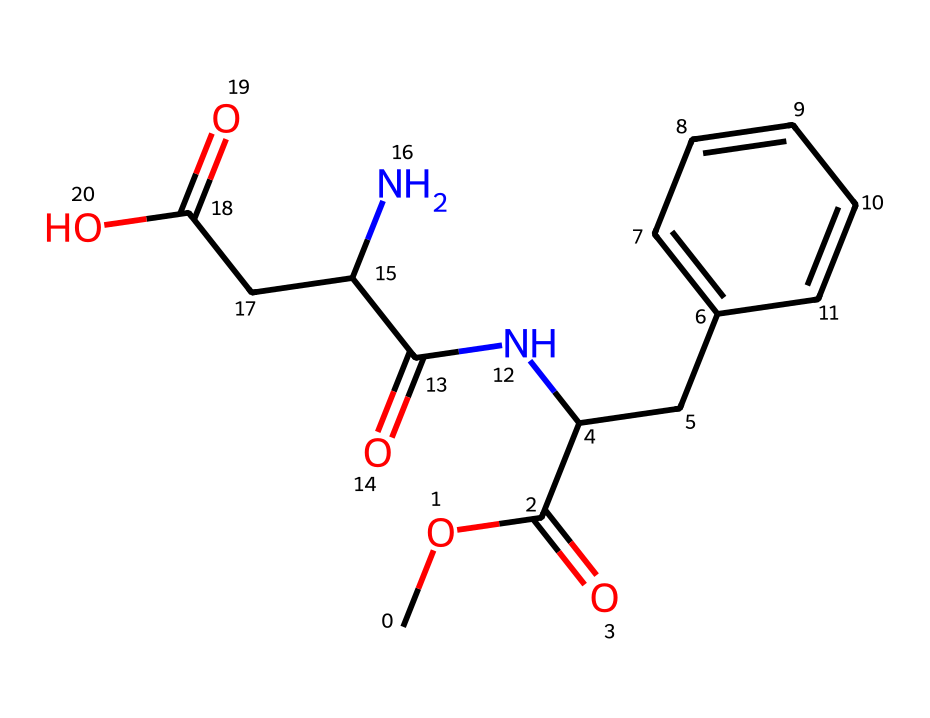what is the name of this compound? This compound is known as aspartame, which is derived from its structure containing both aspartic acid and phenylalanine.
Answer: aspartame how many carbon atoms are present? The SMILES representation indicates that there are 13 carbon atoms in total, as counted from the structure.
Answer: 13 how many nitrogen atoms are in aspartame? Analyzing the SMILES, we see that there are 2 nitrogen atoms present in the structure, represented by the 'N' notation.
Answer: 2 what type of functional groups are present in this molecule? Aspartame contains several functional groups, including ester and amide groups, which are identified by the various connections in the SMILES notation.
Answer: ester and amide what is the molecular formula of aspartame? By counting all the atoms indicated in the SMILES, the molecular formula of aspartame can be derived as C14H18N2O5.
Answer: C14H18N2O5 what is the effect of the phenylalanine moiety in this compound? The phenylalanine portion contributes to the sweetness of aspartame and is also important for its caloric value, as it is an amino acid.
Answer: sweetness does aspartame contain any chiral centers? The structure of aspartame reveals that there are chiral centers present due to the presence of specific carbon atoms bonded to four different substituents.
Answer: yes 